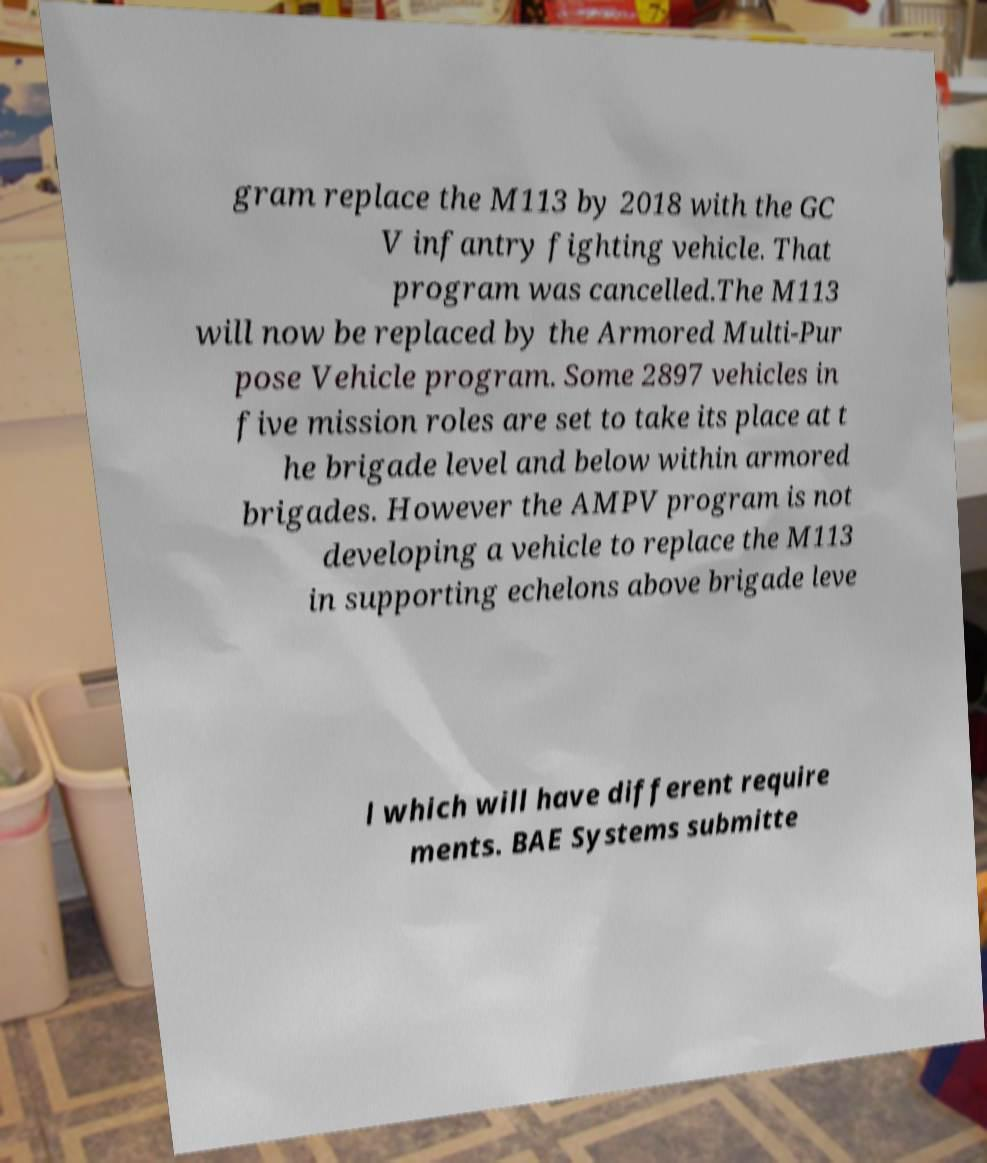Can you accurately transcribe the text from the provided image for me? gram replace the M113 by 2018 with the GC V infantry fighting vehicle. That program was cancelled.The M113 will now be replaced by the Armored Multi-Pur pose Vehicle program. Some 2897 vehicles in five mission roles are set to take its place at t he brigade level and below within armored brigades. However the AMPV program is not developing a vehicle to replace the M113 in supporting echelons above brigade leve l which will have different require ments. BAE Systems submitte 